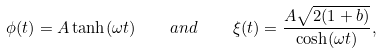<formula> <loc_0><loc_0><loc_500><loc_500>\phi ( t ) = A \tanh ( \omega t ) \quad a n d \quad \xi ( t ) = \frac { A \sqrt { 2 ( 1 + b ) } } { \cosh ( \omega t ) } ,</formula> 